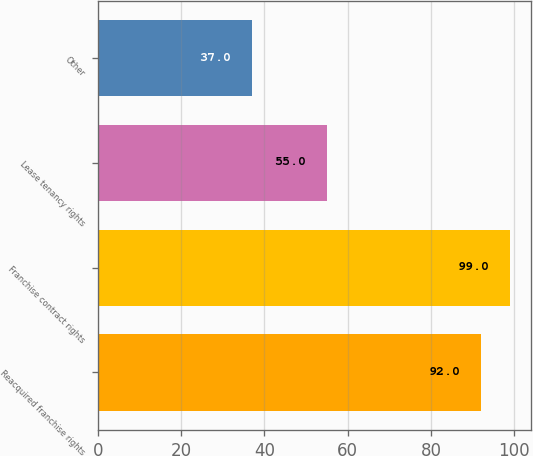Convert chart. <chart><loc_0><loc_0><loc_500><loc_500><bar_chart><fcel>Reacquired franchise rights<fcel>Franchise contract rights<fcel>Lease tenancy rights<fcel>Other<nl><fcel>92<fcel>99<fcel>55<fcel>37<nl></chart> 